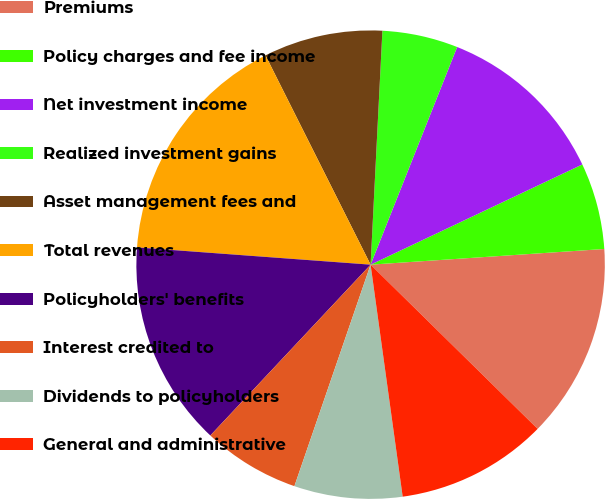<chart> <loc_0><loc_0><loc_500><loc_500><pie_chart><fcel>Premiums<fcel>Policy charges and fee income<fcel>Net investment income<fcel>Realized investment gains<fcel>Asset management fees and<fcel>Total revenues<fcel>Policyholders' benefits<fcel>Interest credited to<fcel>Dividends to policyholders<fcel>General and administrative<nl><fcel>13.43%<fcel>5.97%<fcel>11.94%<fcel>5.22%<fcel>8.21%<fcel>16.42%<fcel>14.18%<fcel>6.72%<fcel>7.46%<fcel>10.45%<nl></chart> 